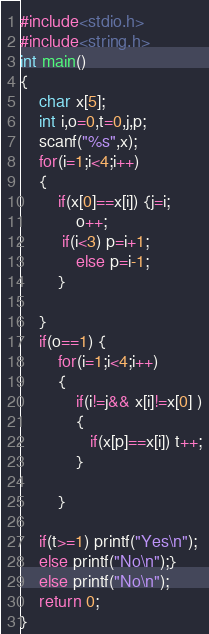<code> <loc_0><loc_0><loc_500><loc_500><_C_>#include<stdio.h>
#include<string.h>
int main()
{
    char x[5];
    int i,o=0,t=0,j,p;
    scanf("%s",x);
    for(i=1;i<4;i++)
    {
        if(x[0]==x[i]) {j=i;
            o++;
         if(i<3) p=i+1;
            else p=i-1;
        }
        
    }
    if(o==1) {
        for(i=1;i<4;i++)
        {
            if(i!=j&& x[i]!=x[0] )
            {
               if(x[p]==x[i]) t++;
            }
            
        }
    
    if(t>=1) printf("Yes\n");
    else printf("No\n");}
    else printf("No\n");
    return 0;
}</code> 